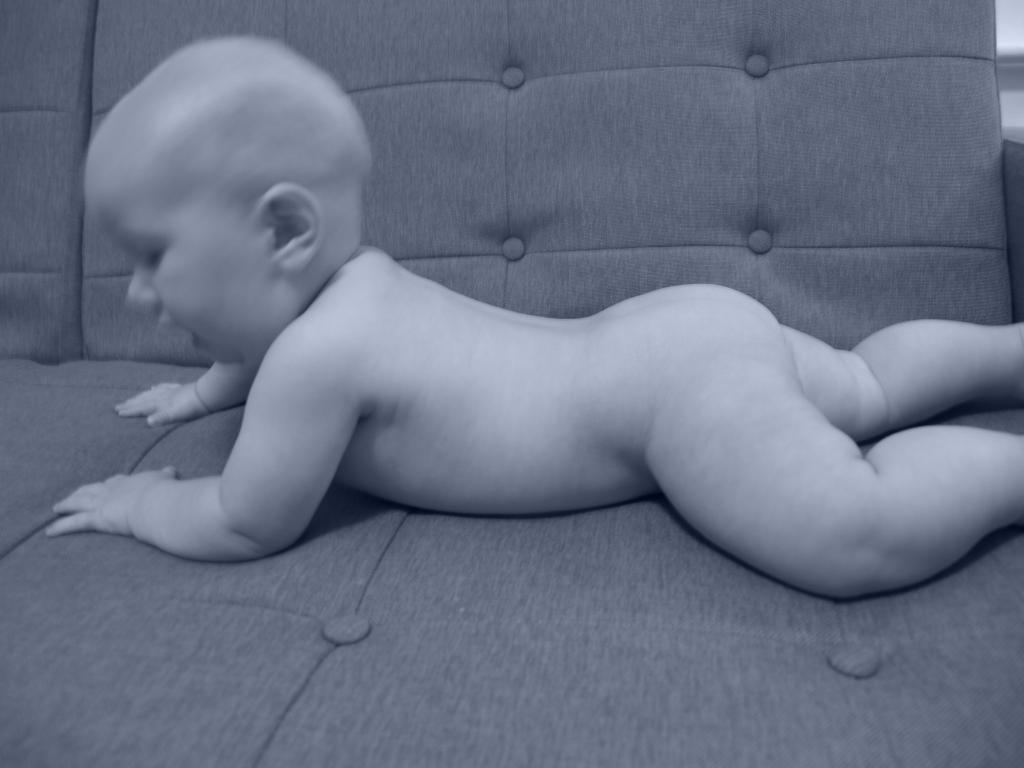What is the color scheme of the picture? The picture is black and white. What is the main subject of the image? There is a baby in the picture. Where is the baby located in the image? The baby is laying on a sofa. What type of twig can be seen in the aftermath of the baby's playtime in the image? There is no twig or mention of playtime in the image; it only shows a baby laying on a sofa in a black and white picture. 